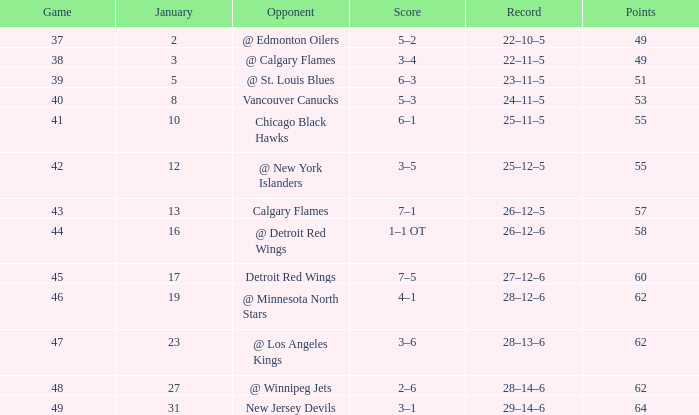How much January has a Record of 26–12–6, and Points smaller than 58? None. 